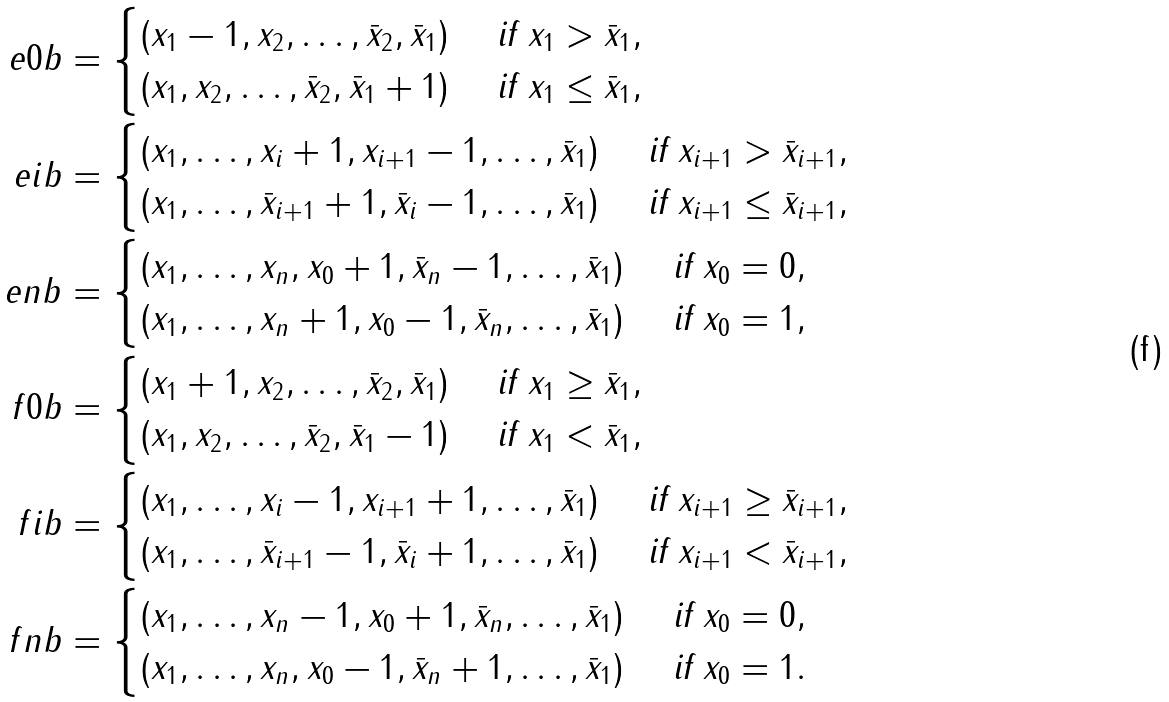<formula> <loc_0><loc_0><loc_500><loc_500>\ e { 0 } b & = \begin{cases} ( x _ { 1 } - 1 , x _ { 2 } , \dots , \bar { x } _ { 2 } , \bar { x } _ { 1 } ) & \text { if } x _ { 1 } > \bar { x } _ { 1 } , \\ ( x _ { 1 } , x _ { 2 } , \dots , \bar { x } _ { 2 } , \bar { x } _ { 1 } + 1 ) & \text { if } x _ { 1 } \leq \bar { x } _ { 1 } , \end{cases} \\ \ e { i } b & = \begin{cases} ( x _ { 1 } , \dots , x _ { i } + 1 , x _ { i + 1 } - 1 , \dots , \bar { x } _ { 1 } ) & \text { if } x _ { i + 1 } > \bar { x } _ { i + 1 } , \\ ( x _ { 1 } , \dots , \bar { x } _ { i + 1 } + 1 , \bar { x } _ { i } - 1 , \dots , \bar { x } _ { 1 } ) & \text { if } x _ { i + 1 } \leq \bar { x } _ { i + 1 } , \\ \end{cases} \\ \ e { n } b & = \begin{cases} ( x _ { 1 } , \dots , x _ { n } , x _ { 0 } + 1 , \bar { x } _ { n } - 1 , \dots , \bar { x } _ { 1 } ) & \text { if } x _ { 0 } = 0 , \\ ( x _ { 1 } , \dots , x _ { n } + 1 , x _ { 0 } - 1 , \bar { x } _ { n } , \dots , \bar { x } _ { 1 } ) & \text { if } x _ { 0 } = 1 , \end{cases} \\ \ f { 0 } b & = \begin{cases} ( x _ { 1 } + 1 , x _ { 2 } , \dots , \bar { x } _ { 2 } , \bar { x } _ { 1 } ) & \text { if } x _ { 1 } \geq \bar { x } _ { 1 } , \\ ( x _ { 1 } , x _ { 2 } , \dots , \bar { x } _ { 2 } , \bar { x } _ { 1 } - 1 ) & \text { if } x _ { 1 } < \bar { x } _ { 1 } , \end{cases} \\ \ f { i } b & = \begin{cases} ( x _ { 1 } , \dots , x _ { i } - 1 , x _ { i + 1 } + 1 , \dots , \bar { x } _ { 1 } ) & \text { if } x _ { i + 1 } \geq \bar { x } _ { i + 1 } , \\ ( x _ { 1 } , \dots , \bar { x } _ { i + 1 } - 1 , \bar { x } _ { i } + 1 , \dots , \bar { x } _ { 1 } ) & \text { if } x _ { i + 1 } < \bar { x } _ { i + 1 } , \\ \end{cases} \\ \ f { n } b & = \begin{cases} ( x _ { 1 } , \dots , x _ { n } - 1 , x _ { 0 } + 1 , \bar { x } _ { n } , \dots , \bar { x } _ { 1 } ) & \text { if } x _ { 0 } = 0 , \\ ( x _ { 1 } , \dots , x _ { n } , x _ { 0 } - 1 , \bar { x } _ { n } + 1 , \dots , \bar { x } _ { 1 } ) & \text { if } x _ { 0 } = 1 . \end{cases}</formula> 